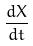<formula> <loc_0><loc_0><loc_500><loc_500>\frac { d X } { d t }</formula> 